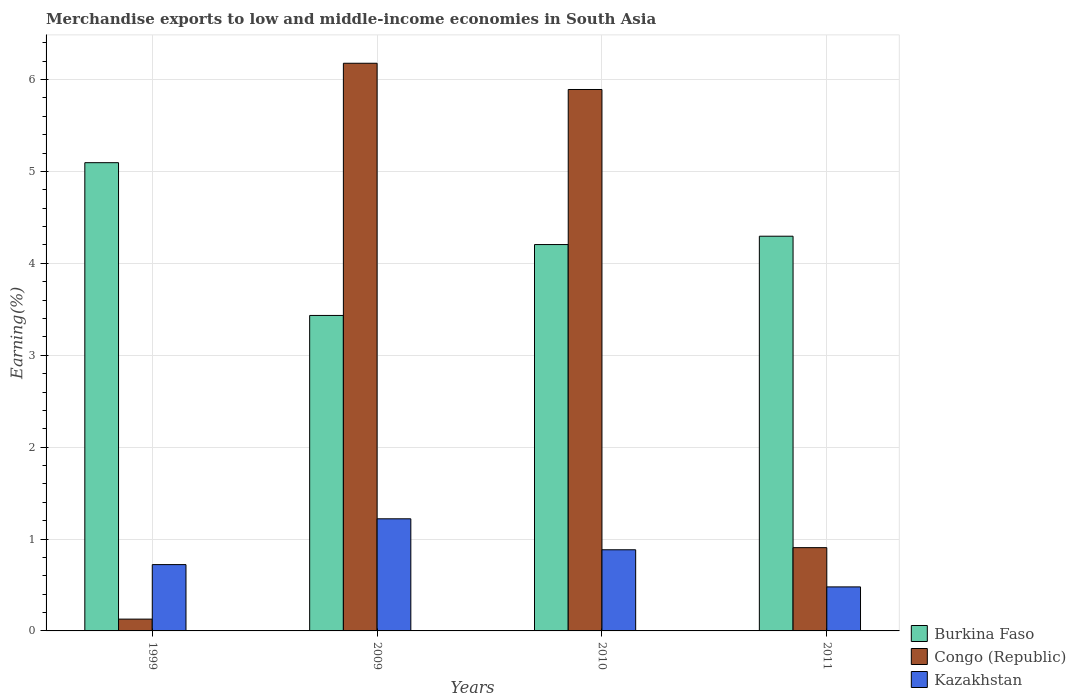How many different coloured bars are there?
Give a very brief answer. 3. How many groups of bars are there?
Your response must be concise. 4. Are the number of bars per tick equal to the number of legend labels?
Offer a terse response. Yes. Are the number of bars on each tick of the X-axis equal?
Ensure brevity in your answer.  Yes. How many bars are there on the 4th tick from the right?
Your response must be concise. 3. In how many cases, is the number of bars for a given year not equal to the number of legend labels?
Make the answer very short. 0. What is the percentage of amount earned from merchandise exports in Congo (Republic) in 2011?
Ensure brevity in your answer.  0.91. Across all years, what is the maximum percentage of amount earned from merchandise exports in Burkina Faso?
Your answer should be compact. 5.1. Across all years, what is the minimum percentage of amount earned from merchandise exports in Congo (Republic)?
Provide a succinct answer. 0.13. What is the total percentage of amount earned from merchandise exports in Kazakhstan in the graph?
Your answer should be very brief. 3.3. What is the difference between the percentage of amount earned from merchandise exports in Burkina Faso in 2010 and that in 2011?
Your answer should be very brief. -0.09. What is the difference between the percentage of amount earned from merchandise exports in Kazakhstan in 2011 and the percentage of amount earned from merchandise exports in Burkina Faso in 2010?
Provide a short and direct response. -3.73. What is the average percentage of amount earned from merchandise exports in Burkina Faso per year?
Provide a short and direct response. 4.26. In the year 2011, what is the difference between the percentage of amount earned from merchandise exports in Burkina Faso and percentage of amount earned from merchandise exports in Kazakhstan?
Your response must be concise. 3.82. What is the ratio of the percentage of amount earned from merchandise exports in Congo (Republic) in 1999 to that in 2009?
Your answer should be compact. 0.02. Is the percentage of amount earned from merchandise exports in Congo (Republic) in 2009 less than that in 2010?
Ensure brevity in your answer.  No. Is the difference between the percentage of amount earned from merchandise exports in Burkina Faso in 1999 and 2009 greater than the difference between the percentage of amount earned from merchandise exports in Kazakhstan in 1999 and 2009?
Offer a very short reply. Yes. What is the difference between the highest and the second highest percentage of amount earned from merchandise exports in Kazakhstan?
Provide a succinct answer. 0.34. What is the difference between the highest and the lowest percentage of amount earned from merchandise exports in Burkina Faso?
Offer a terse response. 1.66. In how many years, is the percentage of amount earned from merchandise exports in Congo (Republic) greater than the average percentage of amount earned from merchandise exports in Congo (Republic) taken over all years?
Give a very brief answer. 2. Is the sum of the percentage of amount earned from merchandise exports in Congo (Republic) in 2009 and 2010 greater than the maximum percentage of amount earned from merchandise exports in Burkina Faso across all years?
Offer a very short reply. Yes. What does the 3rd bar from the left in 2011 represents?
Give a very brief answer. Kazakhstan. What does the 3rd bar from the right in 2010 represents?
Your response must be concise. Burkina Faso. Is it the case that in every year, the sum of the percentage of amount earned from merchandise exports in Burkina Faso and percentage of amount earned from merchandise exports in Congo (Republic) is greater than the percentage of amount earned from merchandise exports in Kazakhstan?
Keep it short and to the point. Yes. How many bars are there?
Ensure brevity in your answer.  12. Are the values on the major ticks of Y-axis written in scientific E-notation?
Your answer should be very brief. No. What is the title of the graph?
Make the answer very short. Merchandise exports to low and middle-income economies in South Asia. What is the label or title of the X-axis?
Offer a very short reply. Years. What is the label or title of the Y-axis?
Offer a terse response. Earning(%). What is the Earning(%) in Burkina Faso in 1999?
Your answer should be very brief. 5.1. What is the Earning(%) in Congo (Republic) in 1999?
Ensure brevity in your answer.  0.13. What is the Earning(%) of Kazakhstan in 1999?
Give a very brief answer. 0.72. What is the Earning(%) in Burkina Faso in 2009?
Provide a succinct answer. 3.43. What is the Earning(%) of Congo (Republic) in 2009?
Offer a very short reply. 6.18. What is the Earning(%) of Kazakhstan in 2009?
Give a very brief answer. 1.22. What is the Earning(%) of Burkina Faso in 2010?
Your answer should be very brief. 4.2. What is the Earning(%) in Congo (Republic) in 2010?
Provide a succinct answer. 5.89. What is the Earning(%) in Kazakhstan in 2010?
Provide a succinct answer. 0.88. What is the Earning(%) in Burkina Faso in 2011?
Offer a terse response. 4.3. What is the Earning(%) in Congo (Republic) in 2011?
Your response must be concise. 0.91. What is the Earning(%) of Kazakhstan in 2011?
Provide a short and direct response. 0.48. Across all years, what is the maximum Earning(%) of Burkina Faso?
Offer a very short reply. 5.1. Across all years, what is the maximum Earning(%) in Congo (Republic)?
Offer a very short reply. 6.18. Across all years, what is the maximum Earning(%) in Kazakhstan?
Make the answer very short. 1.22. Across all years, what is the minimum Earning(%) of Burkina Faso?
Keep it short and to the point. 3.43. Across all years, what is the minimum Earning(%) of Congo (Republic)?
Offer a terse response. 0.13. Across all years, what is the minimum Earning(%) of Kazakhstan?
Provide a short and direct response. 0.48. What is the total Earning(%) in Burkina Faso in the graph?
Keep it short and to the point. 17.03. What is the total Earning(%) in Congo (Republic) in the graph?
Make the answer very short. 13.1. What is the total Earning(%) in Kazakhstan in the graph?
Offer a very short reply. 3.3. What is the difference between the Earning(%) in Burkina Faso in 1999 and that in 2009?
Offer a terse response. 1.66. What is the difference between the Earning(%) in Congo (Republic) in 1999 and that in 2009?
Keep it short and to the point. -6.05. What is the difference between the Earning(%) of Kazakhstan in 1999 and that in 2009?
Provide a succinct answer. -0.5. What is the difference between the Earning(%) of Burkina Faso in 1999 and that in 2010?
Give a very brief answer. 0.89. What is the difference between the Earning(%) of Congo (Republic) in 1999 and that in 2010?
Provide a short and direct response. -5.76. What is the difference between the Earning(%) of Kazakhstan in 1999 and that in 2010?
Ensure brevity in your answer.  -0.16. What is the difference between the Earning(%) of Burkina Faso in 1999 and that in 2011?
Make the answer very short. 0.8. What is the difference between the Earning(%) of Congo (Republic) in 1999 and that in 2011?
Offer a terse response. -0.78. What is the difference between the Earning(%) of Kazakhstan in 1999 and that in 2011?
Give a very brief answer. 0.24. What is the difference between the Earning(%) in Burkina Faso in 2009 and that in 2010?
Your response must be concise. -0.77. What is the difference between the Earning(%) of Congo (Republic) in 2009 and that in 2010?
Offer a terse response. 0.29. What is the difference between the Earning(%) of Kazakhstan in 2009 and that in 2010?
Provide a succinct answer. 0.34. What is the difference between the Earning(%) in Burkina Faso in 2009 and that in 2011?
Offer a very short reply. -0.86. What is the difference between the Earning(%) in Congo (Republic) in 2009 and that in 2011?
Your response must be concise. 5.27. What is the difference between the Earning(%) of Kazakhstan in 2009 and that in 2011?
Ensure brevity in your answer.  0.74. What is the difference between the Earning(%) in Burkina Faso in 2010 and that in 2011?
Make the answer very short. -0.09. What is the difference between the Earning(%) in Congo (Republic) in 2010 and that in 2011?
Give a very brief answer. 4.99. What is the difference between the Earning(%) in Kazakhstan in 2010 and that in 2011?
Keep it short and to the point. 0.4. What is the difference between the Earning(%) of Burkina Faso in 1999 and the Earning(%) of Congo (Republic) in 2009?
Provide a succinct answer. -1.08. What is the difference between the Earning(%) in Burkina Faso in 1999 and the Earning(%) in Kazakhstan in 2009?
Provide a succinct answer. 3.88. What is the difference between the Earning(%) in Congo (Republic) in 1999 and the Earning(%) in Kazakhstan in 2009?
Keep it short and to the point. -1.09. What is the difference between the Earning(%) in Burkina Faso in 1999 and the Earning(%) in Congo (Republic) in 2010?
Make the answer very short. -0.8. What is the difference between the Earning(%) of Burkina Faso in 1999 and the Earning(%) of Kazakhstan in 2010?
Offer a very short reply. 4.21. What is the difference between the Earning(%) in Congo (Republic) in 1999 and the Earning(%) in Kazakhstan in 2010?
Give a very brief answer. -0.75. What is the difference between the Earning(%) in Burkina Faso in 1999 and the Earning(%) in Congo (Republic) in 2011?
Your response must be concise. 4.19. What is the difference between the Earning(%) in Burkina Faso in 1999 and the Earning(%) in Kazakhstan in 2011?
Make the answer very short. 4.62. What is the difference between the Earning(%) in Congo (Republic) in 1999 and the Earning(%) in Kazakhstan in 2011?
Make the answer very short. -0.35. What is the difference between the Earning(%) in Burkina Faso in 2009 and the Earning(%) in Congo (Republic) in 2010?
Provide a short and direct response. -2.46. What is the difference between the Earning(%) of Burkina Faso in 2009 and the Earning(%) of Kazakhstan in 2010?
Ensure brevity in your answer.  2.55. What is the difference between the Earning(%) of Congo (Republic) in 2009 and the Earning(%) of Kazakhstan in 2010?
Your response must be concise. 5.29. What is the difference between the Earning(%) of Burkina Faso in 2009 and the Earning(%) of Congo (Republic) in 2011?
Make the answer very short. 2.53. What is the difference between the Earning(%) of Burkina Faso in 2009 and the Earning(%) of Kazakhstan in 2011?
Provide a succinct answer. 2.95. What is the difference between the Earning(%) of Congo (Republic) in 2009 and the Earning(%) of Kazakhstan in 2011?
Provide a succinct answer. 5.7. What is the difference between the Earning(%) in Burkina Faso in 2010 and the Earning(%) in Congo (Republic) in 2011?
Your answer should be very brief. 3.3. What is the difference between the Earning(%) of Burkina Faso in 2010 and the Earning(%) of Kazakhstan in 2011?
Give a very brief answer. 3.73. What is the difference between the Earning(%) of Congo (Republic) in 2010 and the Earning(%) of Kazakhstan in 2011?
Give a very brief answer. 5.41. What is the average Earning(%) in Burkina Faso per year?
Make the answer very short. 4.26. What is the average Earning(%) in Congo (Republic) per year?
Offer a terse response. 3.28. What is the average Earning(%) of Kazakhstan per year?
Offer a terse response. 0.83. In the year 1999, what is the difference between the Earning(%) of Burkina Faso and Earning(%) of Congo (Republic)?
Provide a succinct answer. 4.97. In the year 1999, what is the difference between the Earning(%) of Burkina Faso and Earning(%) of Kazakhstan?
Keep it short and to the point. 4.37. In the year 1999, what is the difference between the Earning(%) of Congo (Republic) and Earning(%) of Kazakhstan?
Your response must be concise. -0.59. In the year 2009, what is the difference between the Earning(%) in Burkina Faso and Earning(%) in Congo (Republic)?
Provide a short and direct response. -2.74. In the year 2009, what is the difference between the Earning(%) of Burkina Faso and Earning(%) of Kazakhstan?
Ensure brevity in your answer.  2.21. In the year 2009, what is the difference between the Earning(%) in Congo (Republic) and Earning(%) in Kazakhstan?
Keep it short and to the point. 4.96. In the year 2010, what is the difference between the Earning(%) in Burkina Faso and Earning(%) in Congo (Republic)?
Provide a succinct answer. -1.69. In the year 2010, what is the difference between the Earning(%) in Burkina Faso and Earning(%) in Kazakhstan?
Provide a succinct answer. 3.32. In the year 2010, what is the difference between the Earning(%) of Congo (Republic) and Earning(%) of Kazakhstan?
Your response must be concise. 5.01. In the year 2011, what is the difference between the Earning(%) in Burkina Faso and Earning(%) in Congo (Republic)?
Your answer should be very brief. 3.39. In the year 2011, what is the difference between the Earning(%) in Burkina Faso and Earning(%) in Kazakhstan?
Ensure brevity in your answer.  3.82. In the year 2011, what is the difference between the Earning(%) of Congo (Republic) and Earning(%) of Kazakhstan?
Provide a succinct answer. 0.43. What is the ratio of the Earning(%) in Burkina Faso in 1999 to that in 2009?
Your answer should be compact. 1.48. What is the ratio of the Earning(%) in Congo (Republic) in 1999 to that in 2009?
Your response must be concise. 0.02. What is the ratio of the Earning(%) in Kazakhstan in 1999 to that in 2009?
Offer a very short reply. 0.59. What is the ratio of the Earning(%) in Burkina Faso in 1999 to that in 2010?
Offer a very short reply. 1.21. What is the ratio of the Earning(%) of Congo (Republic) in 1999 to that in 2010?
Provide a succinct answer. 0.02. What is the ratio of the Earning(%) in Kazakhstan in 1999 to that in 2010?
Give a very brief answer. 0.82. What is the ratio of the Earning(%) of Burkina Faso in 1999 to that in 2011?
Your response must be concise. 1.19. What is the ratio of the Earning(%) of Congo (Republic) in 1999 to that in 2011?
Your answer should be very brief. 0.14. What is the ratio of the Earning(%) in Kazakhstan in 1999 to that in 2011?
Keep it short and to the point. 1.51. What is the ratio of the Earning(%) in Burkina Faso in 2009 to that in 2010?
Keep it short and to the point. 0.82. What is the ratio of the Earning(%) in Congo (Republic) in 2009 to that in 2010?
Provide a succinct answer. 1.05. What is the ratio of the Earning(%) in Kazakhstan in 2009 to that in 2010?
Ensure brevity in your answer.  1.38. What is the ratio of the Earning(%) of Burkina Faso in 2009 to that in 2011?
Keep it short and to the point. 0.8. What is the ratio of the Earning(%) in Congo (Republic) in 2009 to that in 2011?
Provide a succinct answer. 6.82. What is the ratio of the Earning(%) of Kazakhstan in 2009 to that in 2011?
Keep it short and to the point. 2.55. What is the ratio of the Earning(%) in Burkina Faso in 2010 to that in 2011?
Provide a short and direct response. 0.98. What is the ratio of the Earning(%) in Congo (Republic) in 2010 to that in 2011?
Give a very brief answer. 6.5. What is the ratio of the Earning(%) in Kazakhstan in 2010 to that in 2011?
Provide a short and direct response. 1.84. What is the difference between the highest and the second highest Earning(%) of Burkina Faso?
Offer a very short reply. 0.8. What is the difference between the highest and the second highest Earning(%) of Congo (Republic)?
Give a very brief answer. 0.29. What is the difference between the highest and the second highest Earning(%) in Kazakhstan?
Give a very brief answer. 0.34. What is the difference between the highest and the lowest Earning(%) in Burkina Faso?
Offer a very short reply. 1.66. What is the difference between the highest and the lowest Earning(%) in Congo (Republic)?
Your answer should be very brief. 6.05. What is the difference between the highest and the lowest Earning(%) of Kazakhstan?
Make the answer very short. 0.74. 